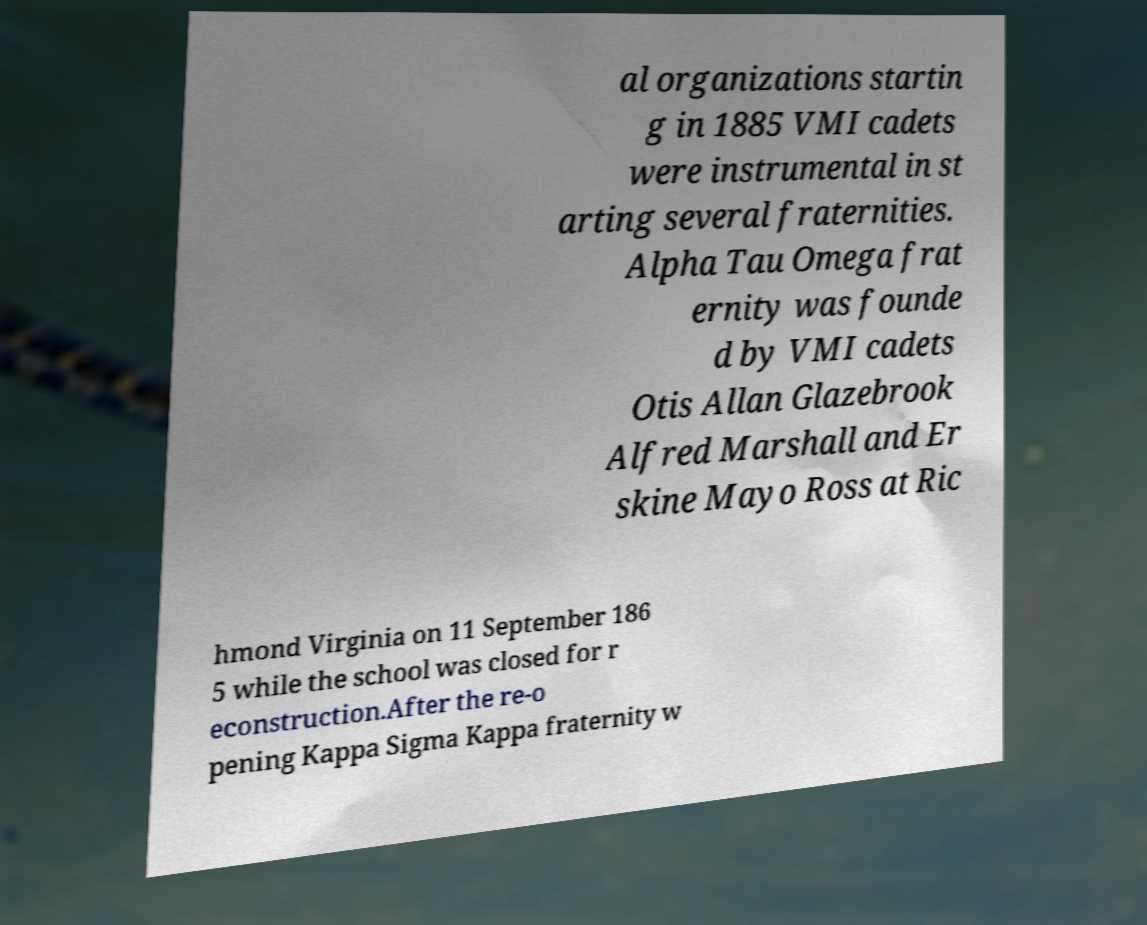Can you accurately transcribe the text from the provided image for me? al organizations startin g in 1885 VMI cadets were instrumental in st arting several fraternities. Alpha Tau Omega frat ernity was founde d by VMI cadets Otis Allan Glazebrook Alfred Marshall and Er skine Mayo Ross at Ric hmond Virginia on 11 September 186 5 while the school was closed for r econstruction.After the re-o pening Kappa Sigma Kappa fraternity w 